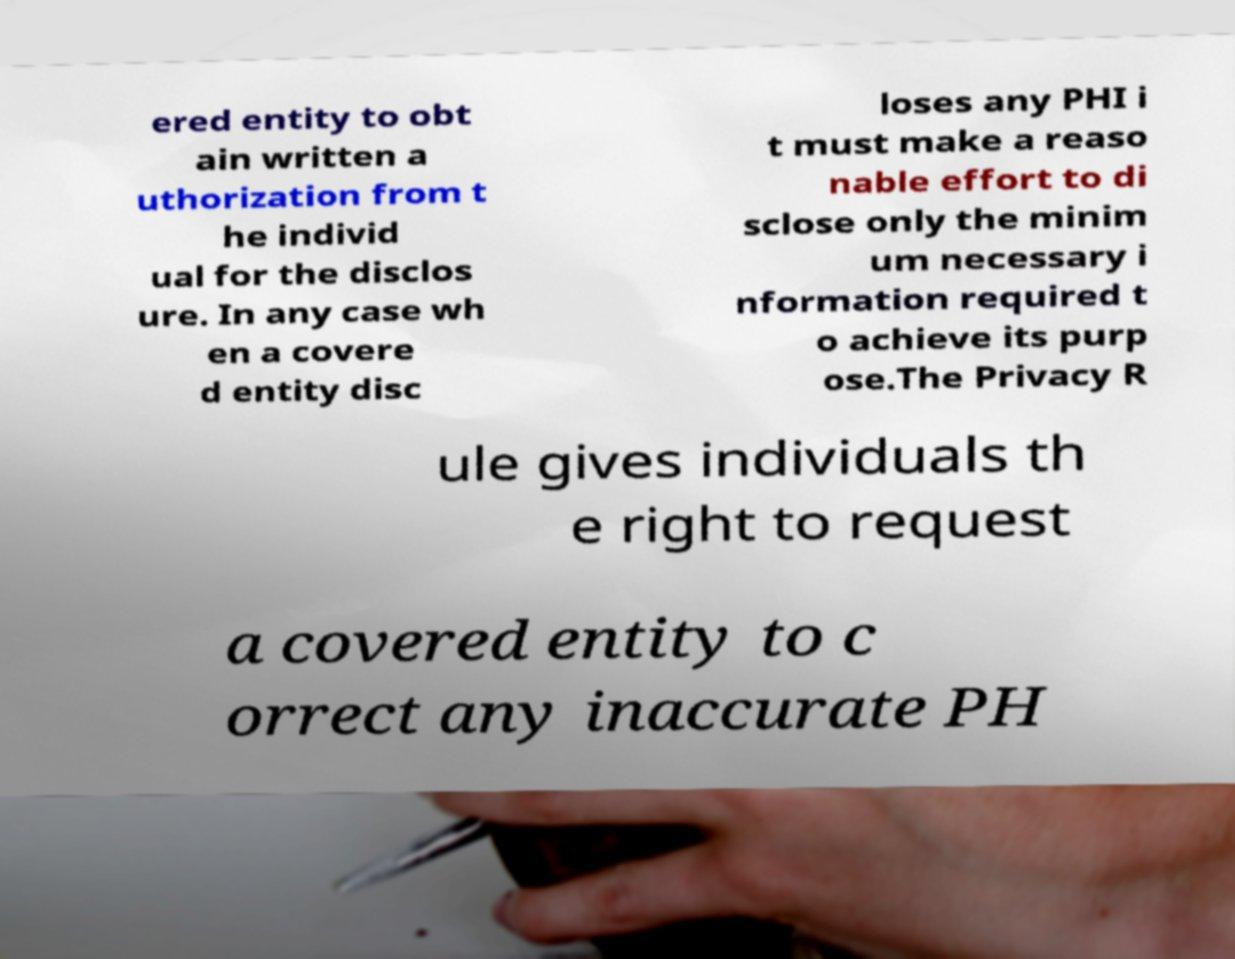For documentation purposes, I need the text within this image transcribed. Could you provide that? ered entity to obt ain written a uthorization from t he individ ual for the disclos ure. In any case wh en a covere d entity disc loses any PHI i t must make a reaso nable effort to di sclose only the minim um necessary i nformation required t o achieve its purp ose.The Privacy R ule gives individuals th e right to request a covered entity to c orrect any inaccurate PH 